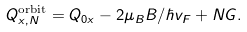<formula> <loc_0><loc_0><loc_500><loc_500>Q _ { x , N } ^ { \text {orbit} } = Q _ { 0 x } - 2 \mu _ { B } B / \hbar { v } _ { F } + N G .</formula> 